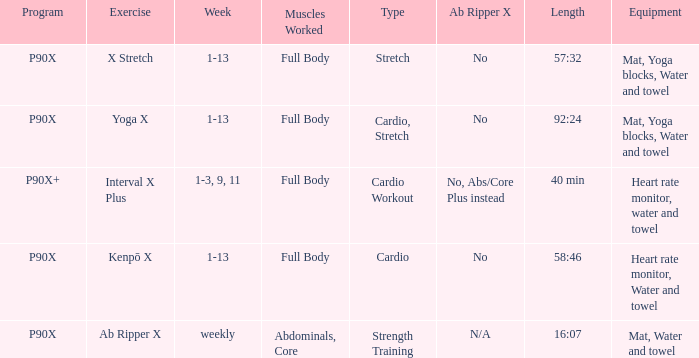What is the ab ripper x when exercise is x stretch? No. 